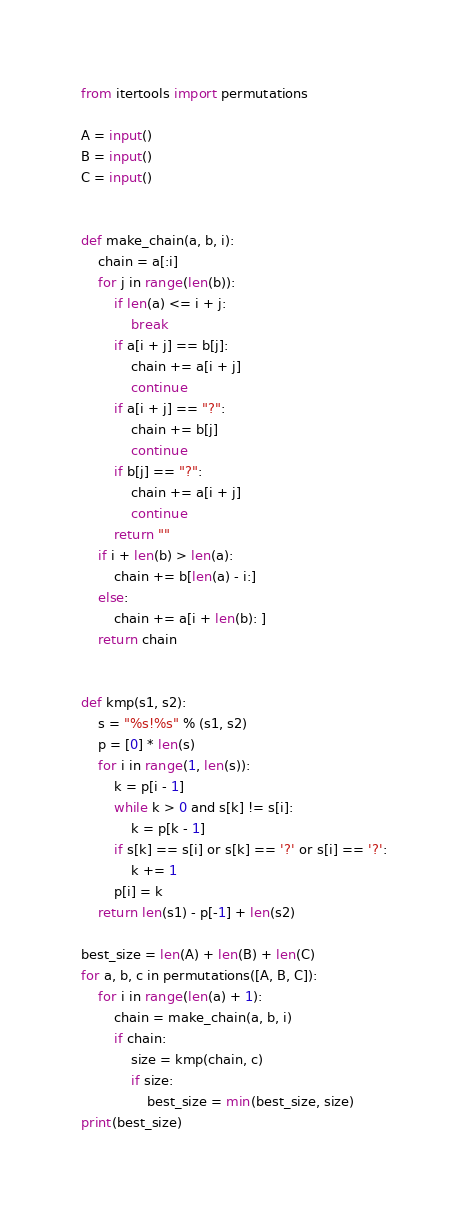Convert code to text. <code><loc_0><loc_0><loc_500><loc_500><_Python_>from itertools import permutations

A = input()
B = input()
C = input()


def make_chain(a, b, i):
    chain = a[:i]
    for j in range(len(b)):
        if len(a) <= i + j:
            break
        if a[i + j] == b[j]:
            chain += a[i + j]
            continue
        if a[i + j] == "?":
            chain += b[j]
            continue
        if b[j] == "?":
            chain += a[i + j]
            continue
        return ""
    if i + len(b) > len(a):
        chain += b[len(a) - i:]
    else:
        chain += a[i + len(b): ]
    return chain


def kmp(s1, s2):
    s = "%s!%s" % (s1, s2)
    p = [0] * len(s)
    for i in range(1, len(s)):
        k = p[i - 1]
        while k > 0 and s[k] != s[i]:
            k = p[k - 1]
        if s[k] == s[i] or s[k] == '?' or s[i] == '?':
            k += 1
        p[i] = k
    return len(s1) - p[-1] + len(s2)

best_size = len(A) + len(B) + len(C)
for a, b, c in permutations([A, B, C]):
    for i in range(len(a) + 1):
        chain = make_chain(a, b, i)
        if chain:
            size = kmp(chain, c)
            if size:
                best_size = min(best_size, size)
print(best_size)



</code> 